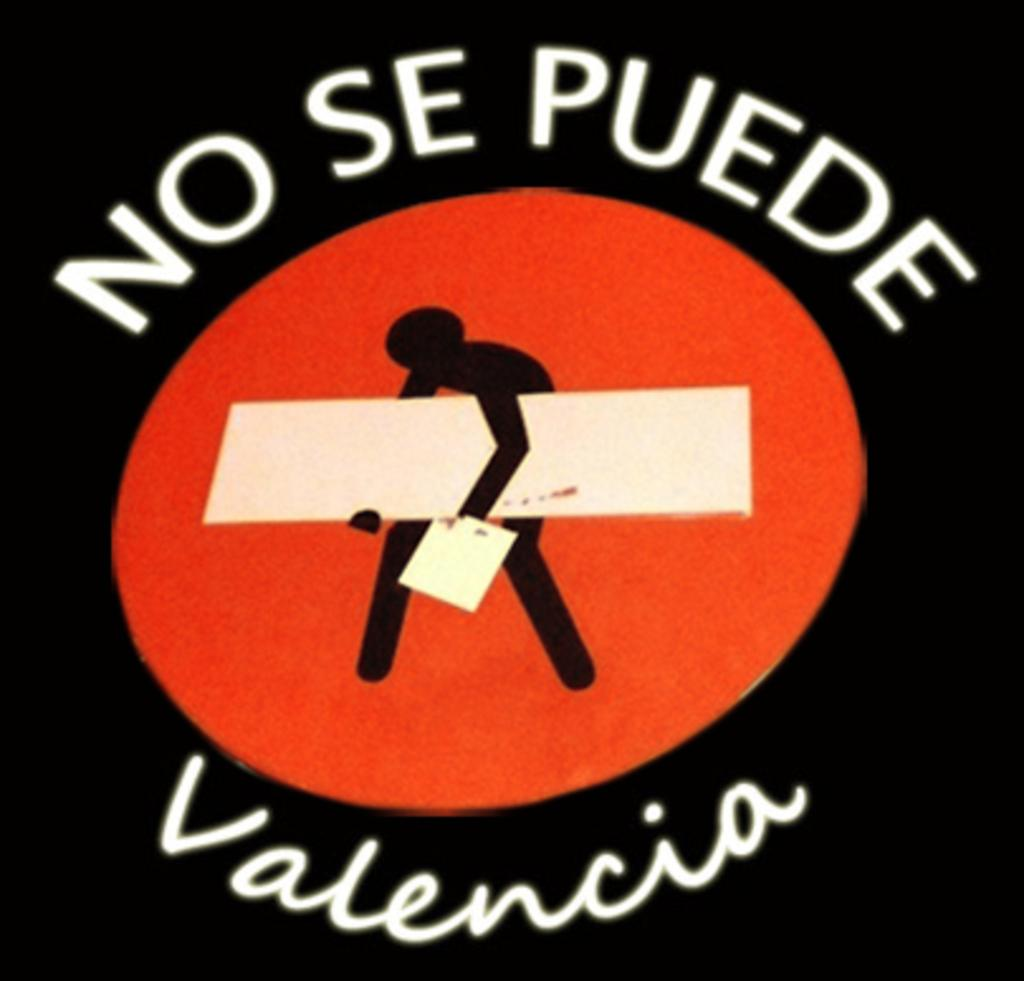<image>
Offer a succinct explanation of the picture presented. A foreign sign. It has a figure of a person carrying a large board and has the words No Se Puede Valencia 